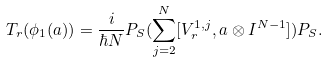Convert formula to latex. <formula><loc_0><loc_0><loc_500><loc_500>T _ { r } ( \phi _ { 1 } ( a ) ) = \frac { i } { \hbar { N } } P _ { S } ( \sum _ { j = 2 } ^ { N } [ V _ { r } ^ { 1 , j } , a \otimes I ^ { N - 1 } ] ) P _ { S } .</formula> 